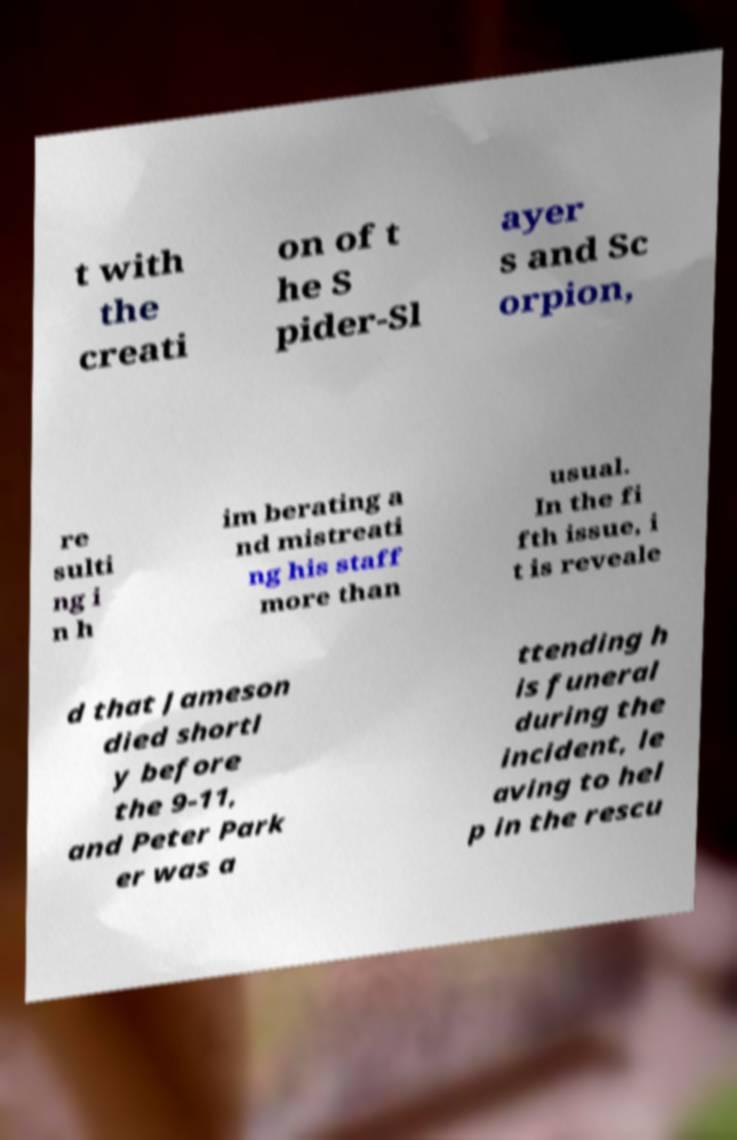What messages or text are displayed in this image? I need them in a readable, typed format. t with the creati on of t he S pider-Sl ayer s and Sc orpion, re sulti ng i n h im berating a nd mistreati ng his staff more than usual. In the fi fth issue, i t is reveale d that Jameson died shortl y before the 9-11, and Peter Park er was a ttending h is funeral during the incident, le aving to hel p in the rescu 